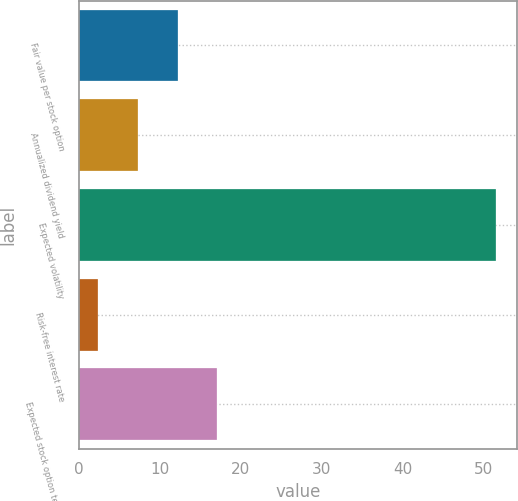Convert chart. <chart><loc_0><loc_0><loc_500><loc_500><bar_chart><fcel>Fair value per stock option<fcel>Annualized dividend yield<fcel>Expected volatility<fcel>Risk-free interest rate<fcel>Expected stock option term (in<nl><fcel>12.22<fcel>7.31<fcel>51.5<fcel>2.4<fcel>17.13<nl></chart> 